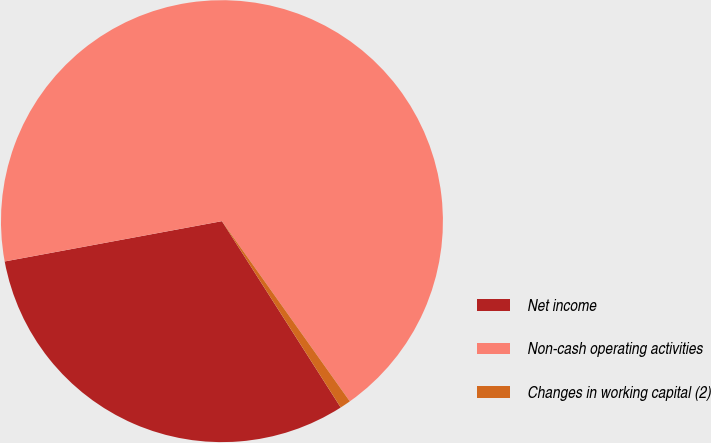<chart> <loc_0><loc_0><loc_500><loc_500><pie_chart><fcel>Net income<fcel>Non-cash operating activities<fcel>Changes in working capital (2)<nl><fcel>31.11%<fcel>68.09%<fcel>0.79%<nl></chart> 